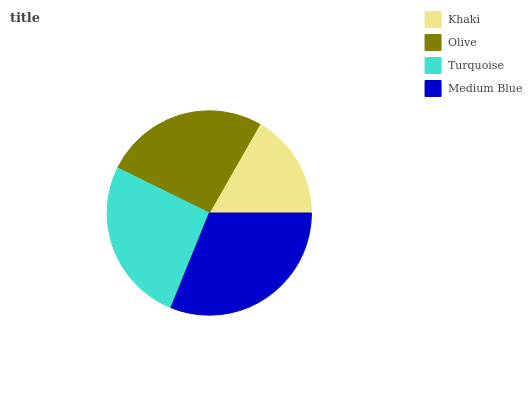Is Khaki the minimum?
Answer yes or no. Yes. Is Medium Blue the maximum?
Answer yes or no. Yes. Is Olive the minimum?
Answer yes or no. No. Is Olive the maximum?
Answer yes or no. No. Is Olive greater than Khaki?
Answer yes or no. Yes. Is Khaki less than Olive?
Answer yes or no. Yes. Is Khaki greater than Olive?
Answer yes or no. No. Is Olive less than Khaki?
Answer yes or no. No. Is Turquoise the high median?
Answer yes or no. Yes. Is Olive the low median?
Answer yes or no. Yes. Is Khaki the high median?
Answer yes or no. No. Is Medium Blue the low median?
Answer yes or no. No. 